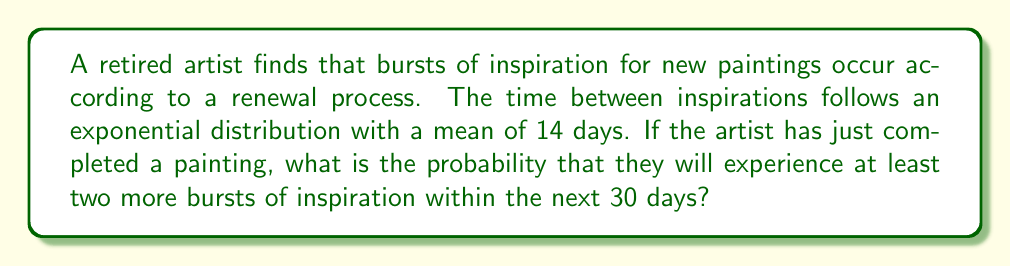What is the answer to this math problem? Let's approach this step-by-step:

1) First, we need to identify the key parameters:
   - The process is a renewal process with exponentially distributed inter-arrival times
   - Mean time between inspirations: $\mu = 14$ days
   - Time period of interest: $T = 30$ days
   - We're interested in the probability of 2 or more inspirations

2) For an exponential distribution, the rate parameter $\lambda$ is the inverse of the mean:
   $$\lambda = \frac{1}{\mu} = \frac{1}{14} \approx 0.0714$$

3) In a Poisson process (which this renewal process becomes due to the exponential inter-arrival times), the number of events in a fixed time interval follows a Poisson distribution. The mean of this Poisson distribution for a time period $T$ is:
   $$\lambda T = 0.0714 \times 30 \approx 2.142$$

4) Let $X$ be the number of inspirations in 30 days. We want $P(X \geq 2)$, which is equivalent to $1 - P(X < 2)$ or $1 - P(X \leq 1)$.

5) Using the Poisson probability mass function:
   $$P(X = k) = \frac{e^{-\lambda T}(\lambda T)^k}{k!}$$

   We can calculate:
   $$P(X \leq 1) = P(X = 0) + P(X = 1)$$
   $$= e^{-2.142} + e^{-2.142} \times 2.142$$
   $$\approx 0.1175 + 0.2516 = 0.3691$$

6) Therefore, the probability of at least two inspirations is:
   $$P(X \geq 2) = 1 - P(X \leq 1) \approx 1 - 0.3691 = 0.6309$$
Answer: 0.6309 